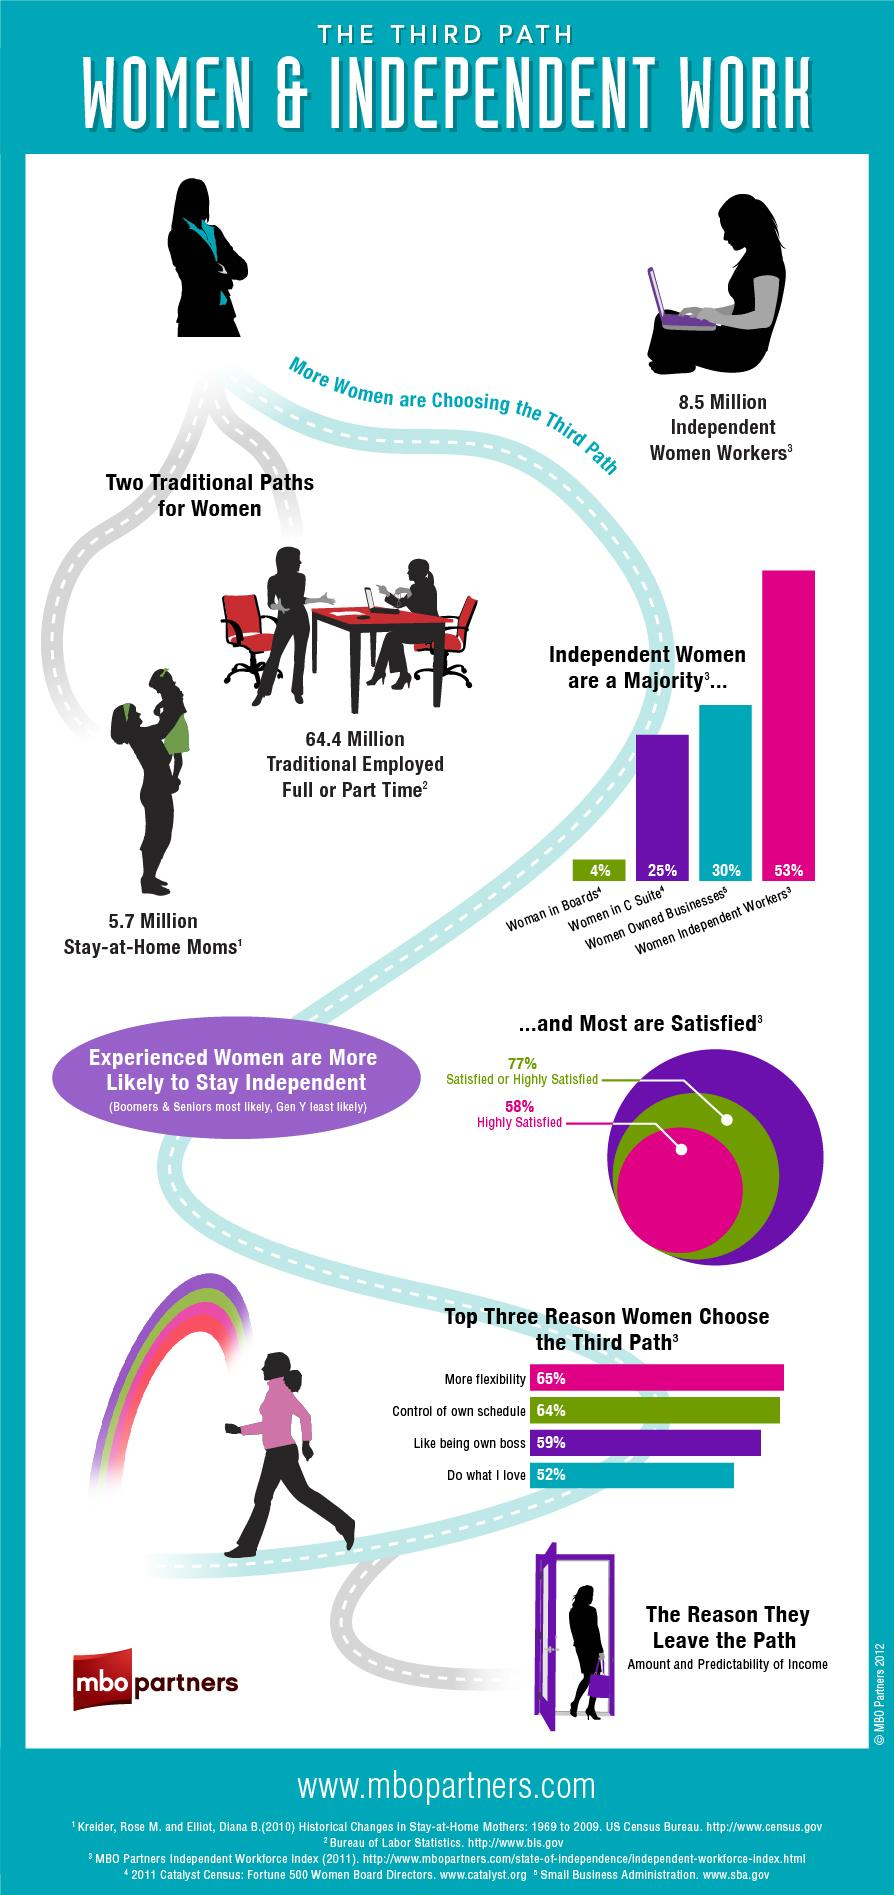Give some essential details in this illustration. According to the survey, 77% of independent women workers are satisfied or highly satisfied. According to the survey, 30% of independent women owned their own businesses. According to the survey, approximately 64.4 million women are either fully or partially employed. 